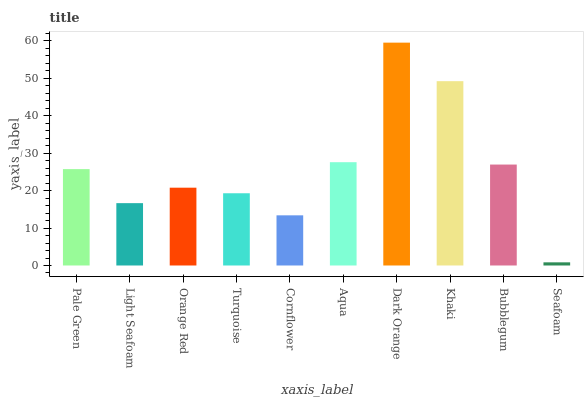Is Seafoam the minimum?
Answer yes or no. Yes. Is Dark Orange the maximum?
Answer yes or no. Yes. Is Light Seafoam the minimum?
Answer yes or no. No. Is Light Seafoam the maximum?
Answer yes or no. No. Is Pale Green greater than Light Seafoam?
Answer yes or no. Yes. Is Light Seafoam less than Pale Green?
Answer yes or no. Yes. Is Light Seafoam greater than Pale Green?
Answer yes or no. No. Is Pale Green less than Light Seafoam?
Answer yes or no. No. Is Pale Green the high median?
Answer yes or no. Yes. Is Orange Red the low median?
Answer yes or no. Yes. Is Seafoam the high median?
Answer yes or no. No. Is Dark Orange the low median?
Answer yes or no. No. 